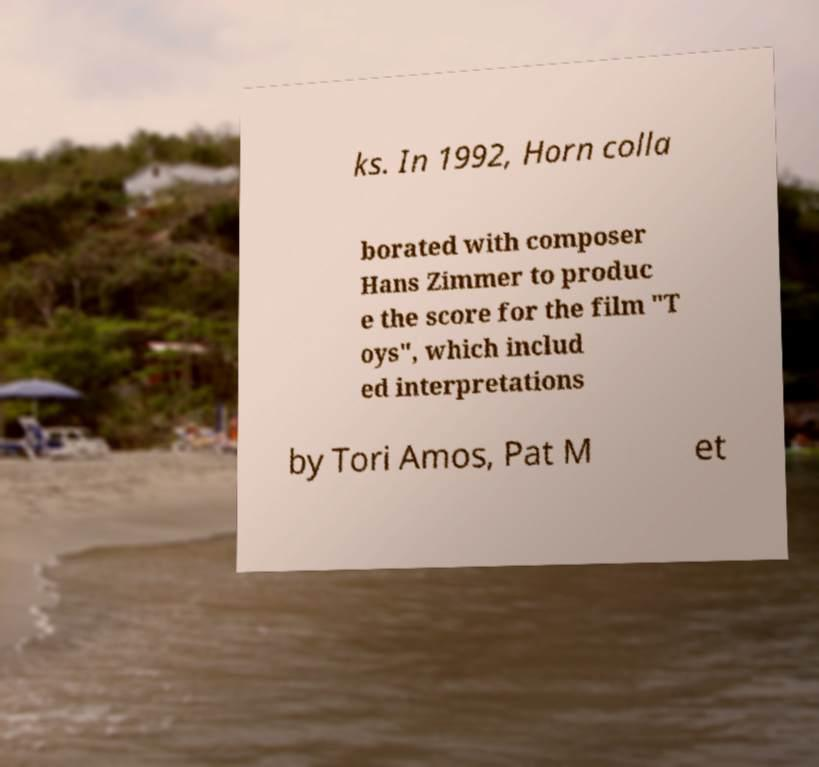Could you assist in decoding the text presented in this image and type it out clearly? ks. In 1992, Horn colla borated with composer Hans Zimmer to produc e the score for the film "T oys", which includ ed interpretations by Tori Amos, Pat M et 